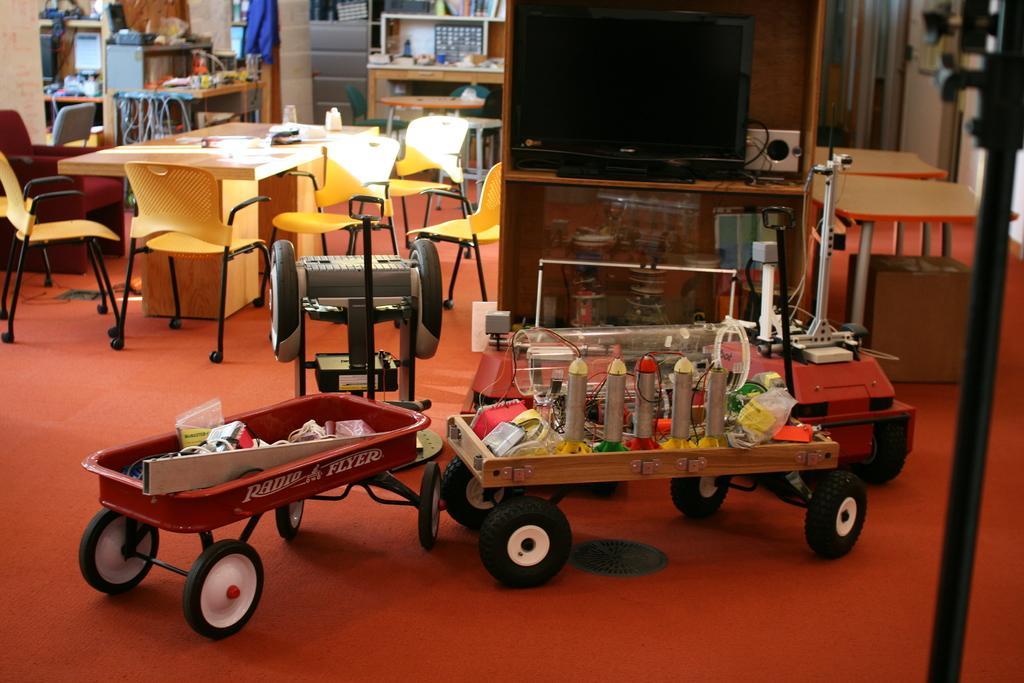How would you summarize this image in a sentence or two? In this image i can see 2 trolleys with few objects in them. In the background i an see a television screen, few chairs, a table, few clothes, few books in the shelf, few monitors, the wall and few other objects. 